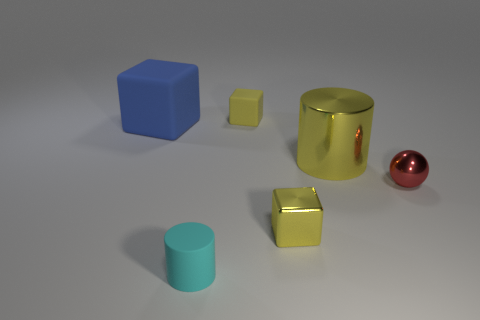Do the blue thing and the cylinder behind the metal block have the same size?
Provide a succinct answer. Yes. What number of things are large rubber blocks or small yellow metallic objects?
Offer a terse response. 2. Are there any other small spheres that have the same material as the sphere?
Your answer should be compact. No. What size is the metal cube that is the same color as the big shiny cylinder?
Your answer should be compact. Small. What is the color of the small cube that is on the right side of the small rubber thing that is behind the small yellow metal object?
Your answer should be very brief. Yellow. Is the size of the blue thing the same as the yellow rubber thing?
Your response must be concise. No. What number of blocks are either cyan rubber things or large metallic things?
Your answer should be very brief. 0. There is a matte block that is in front of the tiny yellow rubber cube; what number of tiny yellow objects are behind it?
Make the answer very short. 1. Is the shape of the tiny yellow matte object the same as the large yellow object?
Your answer should be compact. No. What is the size of the blue matte thing that is the same shape as the small yellow shiny thing?
Provide a succinct answer. Large. 